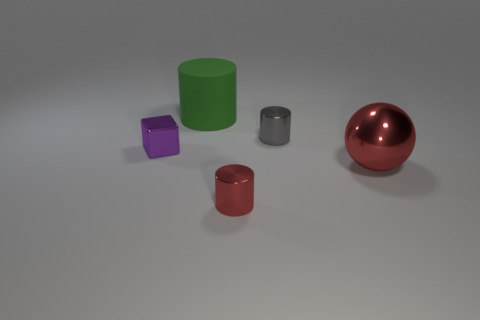Subtract all big matte cylinders. How many cylinders are left? 2 Add 3 big red matte cylinders. How many objects exist? 8 Subtract 1 cylinders. How many cylinders are left? 2 Subtract all gray cylinders. How many cylinders are left? 2 Subtract all spheres. How many objects are left? 4 Add 1 purple things. How many purple things are left? 2 Add 4 matte things. How many matte things exist? 5 Subtract 0 purple cylinders. How many objects are left? 5 Subtract all yellow cubes. Subtract all purple balls. How many cubes are left? 1 Subtract all metal blocks. Subtract all tiny cubes. How many objects are left? 3 